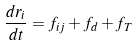Convert formula to latex. <formula><loc_0><loc_0><loc_500><loc_500>\frac { d { r } _ { i } } { d t } = { f } _ { i j } + { f } _ { d } + { f } _ { T }</formula> 